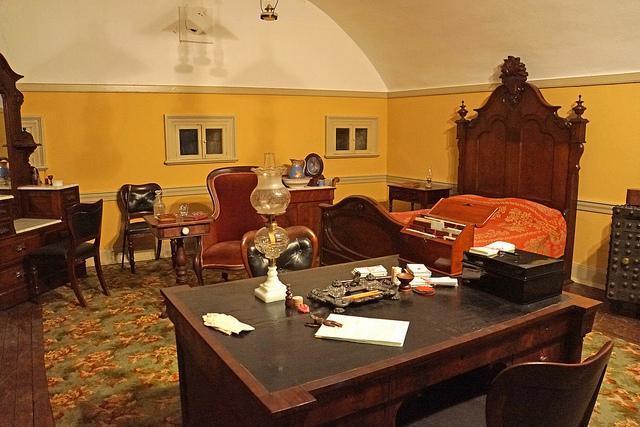How many chairs are in the picture?
Give a very brief answer. 4. 